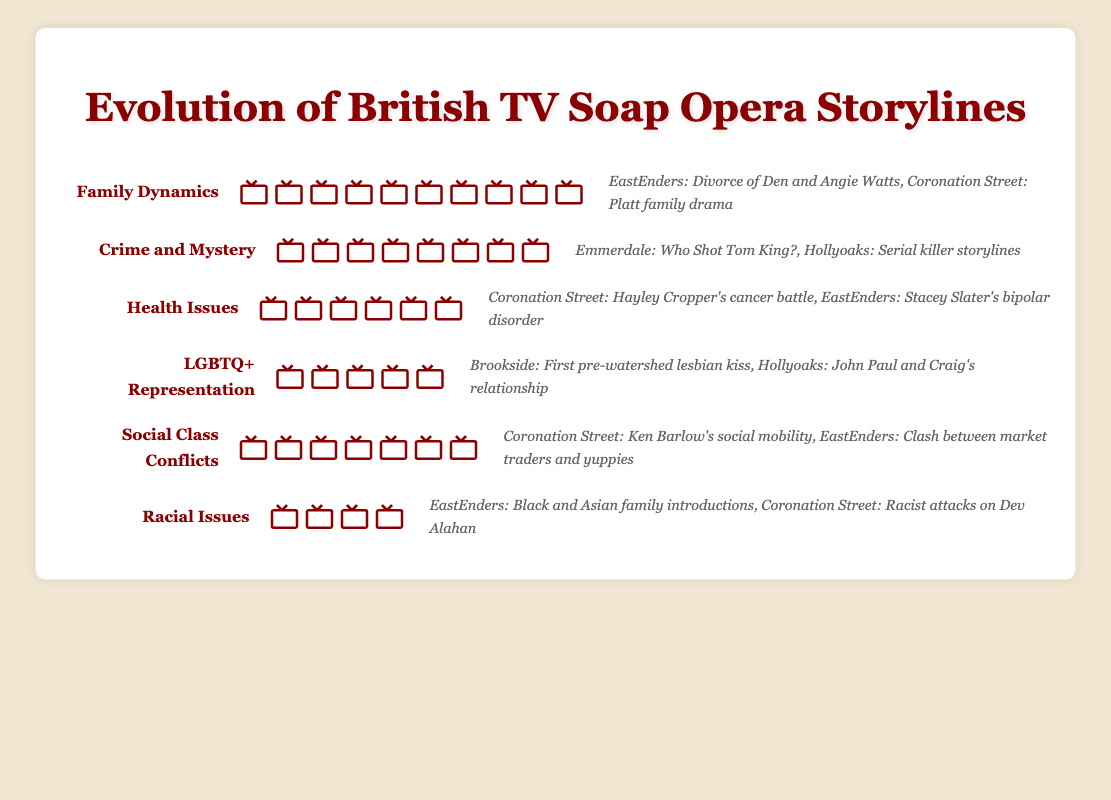What theme features the most icons? To determine which theme features the most icons, look at each theme's row and count the number of icons present. "Family Dynamics" has the most icons with 10.
Answer: Family Dynamics Which theme addresses the least number of social issues? To find the theme addressing the least number of social issues, identify the theme with the fewest icons. "Racial Issues" has the least number of icons, with only 4.
Answer: Racial Issues List two examples of crime and mystery storylines mentioned in the plot. Look at the examples listed in the "Crime and Mystery" row. The examples are "Emmerdale: Who Shot Tom King?" and "Hollyoaks: Serial killer storylines."
Answer: Emmerdale: Who Shot Tom King?, Hollyoaks: Serial killer storylines How does the number of icons for health issues compare to the number of icons for LGBTQ+ representation? Compare the number of icons in the "Health Issues" row, which is 6, to the number of icons in the "LGBTQ+ Representation" row, which is 5. "Health Issues" has 1 more icon than "LGBTQ+ Representation."
Answer: Health Issues has 1 more icon What is the total number of icons representing social class conflicts and racial issues combined? Add the number of icons in the "Social Class Conflicts" row (7) to the number of icons in the "Racial Issues" row (4) to get the total. 7 + 4 = 11.
Answer: 11 Which two themes have closer to an equal number of icons? Compare the number of icons in each row. "Health Issues" (6 icons) and "Social Class Conflicts" (7 icons) have a closer number of icons compared to other themes.
Answer: Health Issues and Social Class Conflicts What is the most frequently represented theme involving a health storyline example provided? Look at the examples given for each theme and find the ones related to health storylines. Then, verify the number of icons across those themes. "Health Issues" is the most represented theme with examples "Coronation Street: Hayley Cropper's cancer battle" and "EastEnders: Stacey Slater's bipolar disorder."
Answer: Health Issues How many themes are discussed in the plot? Count the number of distinct themes listed in the figure. There are six themes: Family Dynamics, Crime and Mystery, Health Issues, LGBTQ+ Representation, Social Class Conflicts, and Racial Issues.
Answer: 6 Which social issue was first addressed pre-watershed according to the examples? Check the examples under each theme for any mention of "pre-watershed." "Brookside: First pre-watershed lesbian kiss" under "LGBTQ+ Representation" is the first mentioned.
Answer: Brookside: First pre-watershed lesbian kiss 